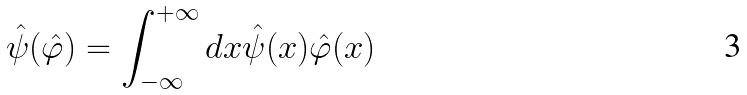Convert formula to latex. <formula><loc_0><loc_0><loc_500><loc_500>\hat { \psi } ( \hat { \varphi } ) = \int _ { - \infty } ^ { + \infty } d x \hat { \psi } ( x ) \hat { \varphi } ( x )</formula> 